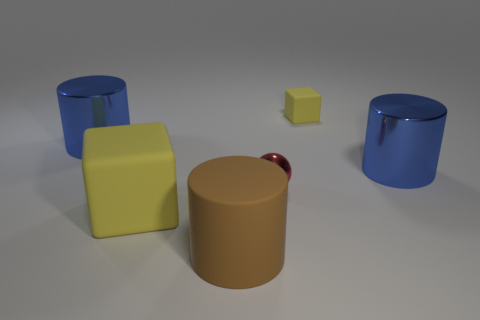How many other things are there of the same color as the small cube?
Your response must be concise. 1. How many purple things are tiny things or tiny metallic objects?
Give a very brief answer. 0. Is the number of large yellow rubber things behind the tiny red thing greater than the number of big yellow cubes?
Give a very brief answer. No. Are there any big cylinders of the same color as the ball?
Ensure brevity in your answer.  No. What is the size of the brown matte cylinder?
Your response must be concise. Large. Do the big matte cube and the ball have the same color?
Give a very brief answer. No. How many objects are either big blue cylinders or metallic objects that are right of the tiny yellow object?
Give a very brief answer. 2. There is a object to the right of the rubber cube behind the red shiny sphere; how many tiny yellow rubber cubes are in front of it?
Your answer should be compact. 0. There is a object that is the same color as the tiny matte block; what is it made of?
Make the answer very short. Rubber. How many tiny purple cylinders are there?
Your answer should be compact. 0. 